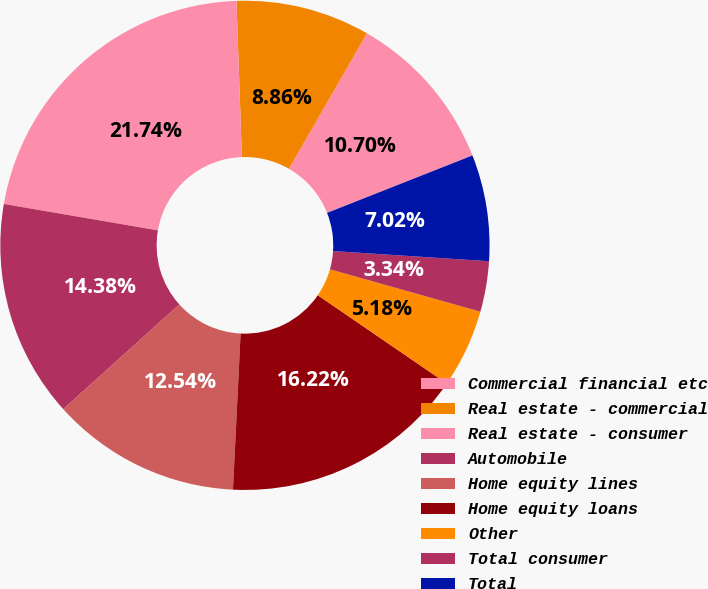<chart> <loc_0><loc_0><loc_500><loc_500><pie_chart><fcel>Commercial financial etc<fcel>Real estate - commercial<fcel>Real estate - consumer<fcel>Automobile<fcel>Home equity lines<fcel>Home equity loans<fcel>Other<fcel>Total consumer<fcel>Total<nl><fcel>10.7%<fcel>8.86%<fcel>21.74%<fcel>14.38%<fcel>12.54%<fcel>16.22%<fcel>5.18%<fcel>3.34%<fcel>7.02%<nl></chart> 